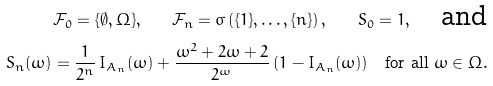Convert formula to latex. <formula><loc_0><loc_0><loc_500><loc_500>\mathcal { F } _ { 0 } = \{ \emptyset , \Omega \} , \quad \mathcal { F } _ { n } = \sigma \left ( \{ 1 \} , \dots , \{ n \} \right ) , \quad S _ { 0 } = 1 , \quad \text {and} \\ S _ { n } ( \omega ) = \frac { 1 } { 2 ^ { n } } \, I _ { A _ { n } } ( \omega ) + \frac { \omega ^ { 2 } + 2 \omega + 2 } { 2 ^ { \omega } } \, ( 1 - I _ { A _ { n } } ( \omega ) ) \quad \text {for all } \omega \in \Omega .</formula> 